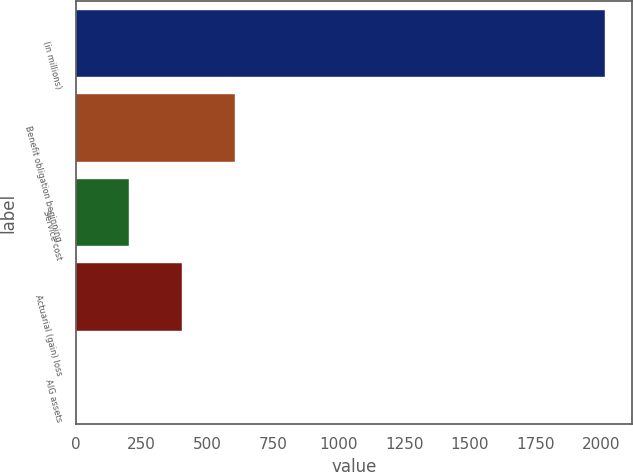Convert chart to OTSL. <chart><loc_0><loc_0><loc_500><loc_500><bar_chart><fcel>(in millions)<fcel>Benefit obligation beginning<fcel>Service cost<fcel>Actuarial (gain) loss<fcel>AIG assets<nl><fcel>2015<fcel>605.2<fcel>202.4<fcel>403.8<fcel>1<nl></chart> 